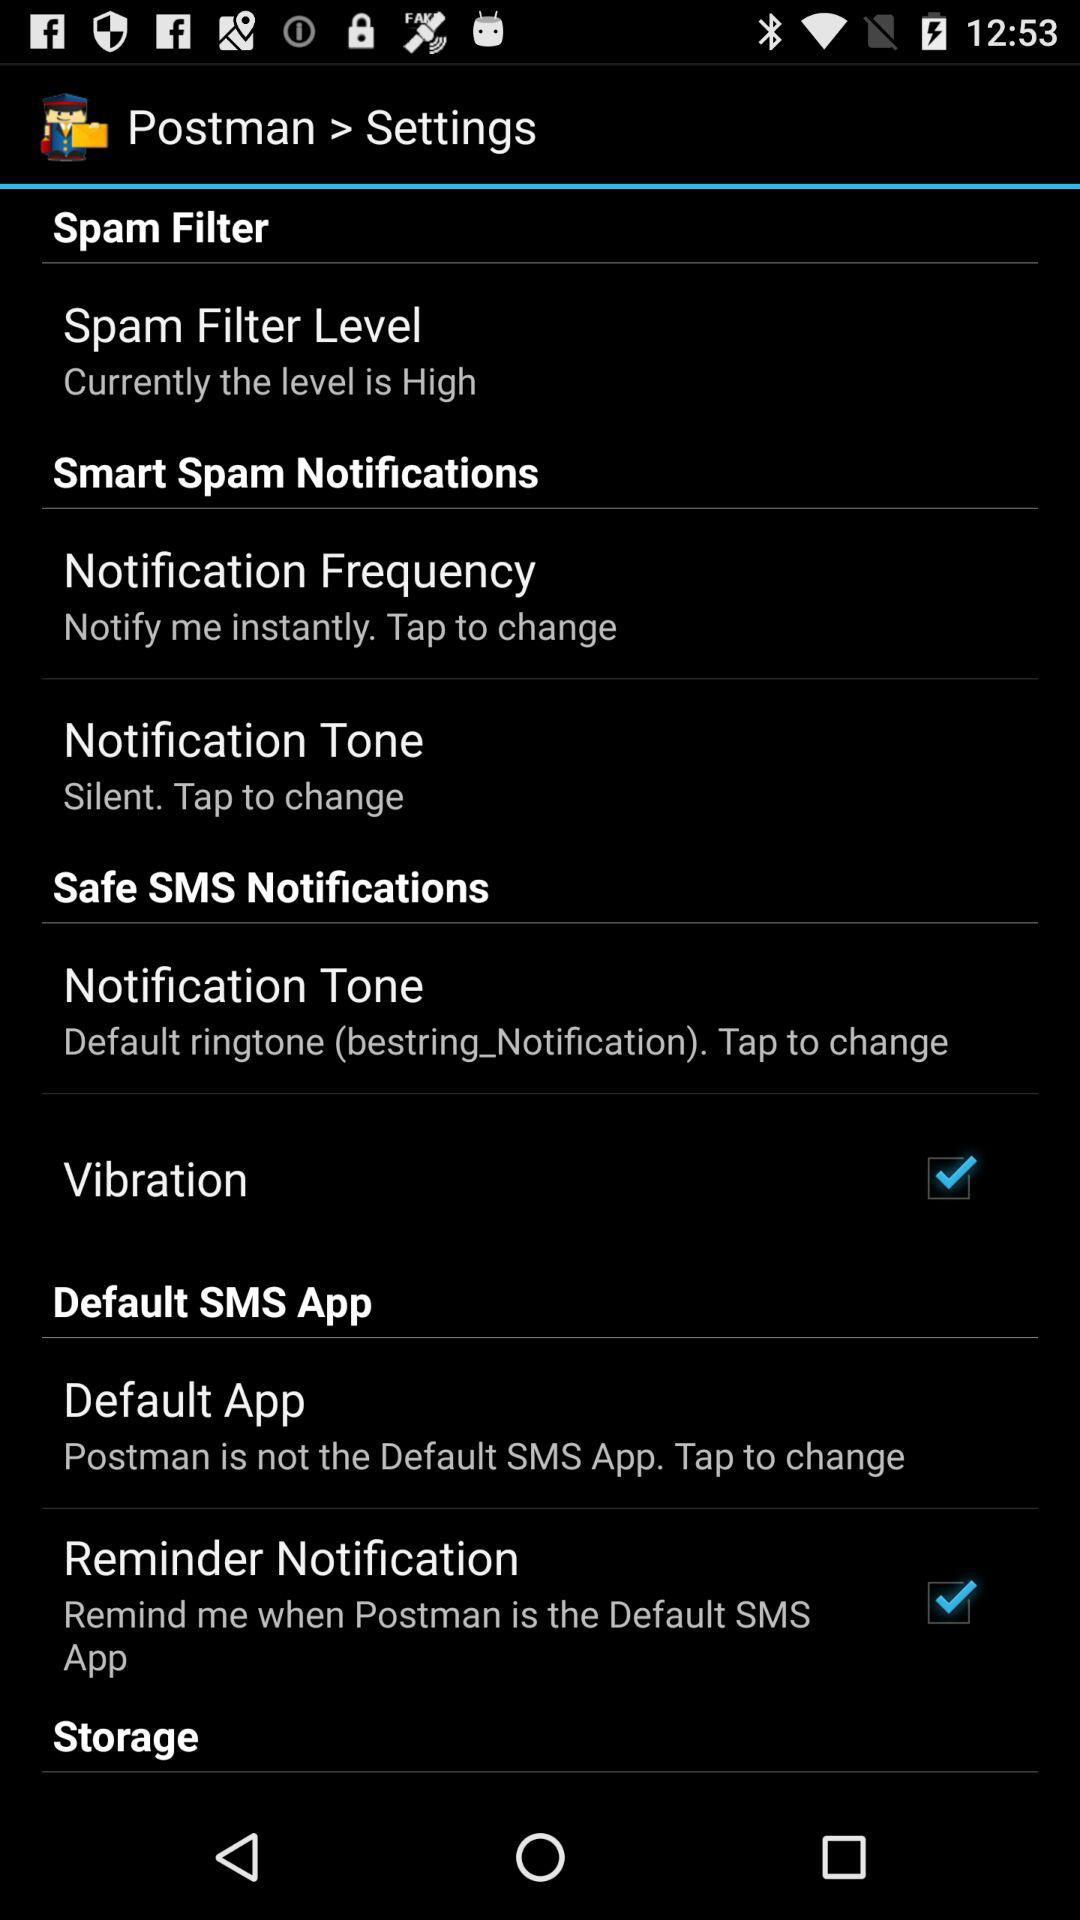Which "Postman" settings are checked? The checked "Postman" settings are "Vibration" and "Reminder Notification". 